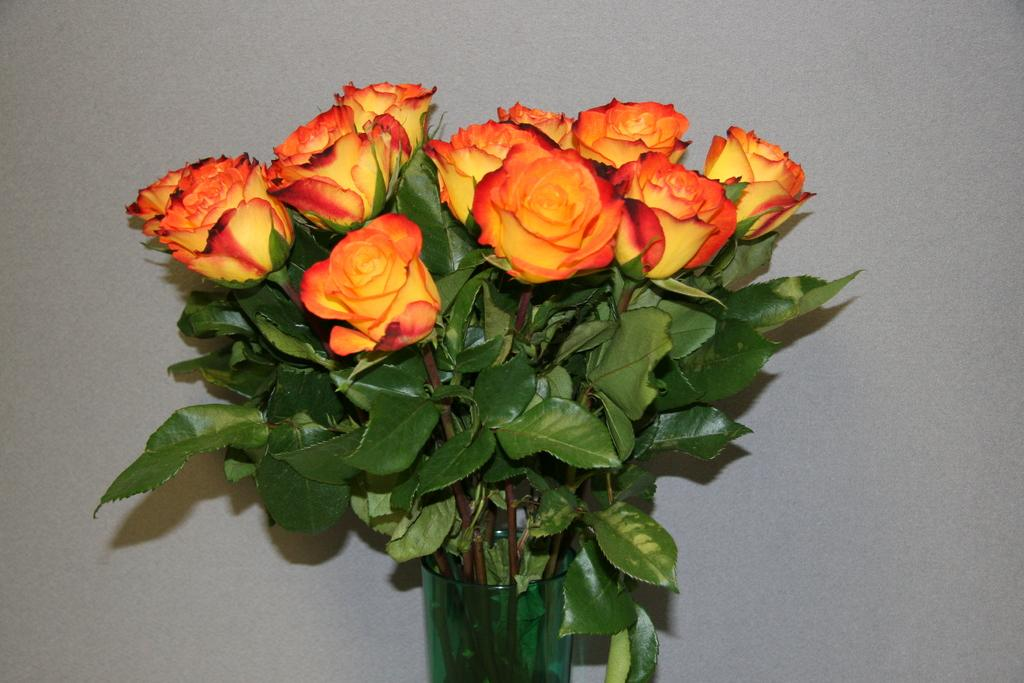What is the main object in the center of the image? There is a flower vase in the center of the image. What is inside the vase? The vase contains flowers and green leaves. What can be seen in the background of the image? There is an object in the background that appears to be a wall. What type of cake is being served on the appliance in the image? There is no cake or appliance present in the image; it features a flower vase with flowers and green leaves, and a wall in the background. 